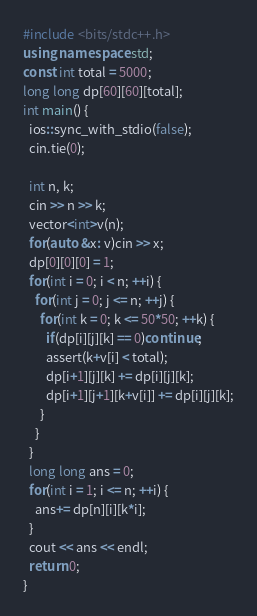Convert code to text. <code><loc_0><loc_0><loc_500><loc_500><_C++_>#include <bits/stdc++.h>
using namespace std;
const int total = 5000;
long long dp[60][60][total];
int main() {
  ios::sync_with_stdio(false);
  cin.tie(0);

  int n, k;
  cin >> n >> k;
  vector<int>v(n);
  for(auto &x: v)cin >> x;
  dp[0][0][0] = 1;
  for(int i = 0; i < n; ++i) {
    for(int j = 0; j <= n; ++j) {
      for(int k = 0; k <= 50*50; ++k) {
        if(dp[i][j][k] == 0)continue;
        assert(k+v[i] < total);
        dp[i+1][j][k] += dp[i][j][k];
        dp[i+1][j+1][k+v[i]] += dp[i][j][k];
      }
    }
  }
  long long ans = 0;
  for(int i = 1; i <= n; ++i) {
    ans+= dp[n][i][k*i];
  }
  cout << ans << endl;
  return 0;
}</code> 